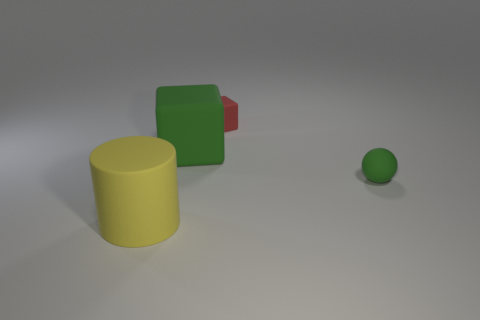Add 3 large yellow objects. How many objects exist? 7 Subtract all spheres. How many objects are left? 3 Subtract 0 red balls. How many objects are left? 4 Subtract all rubber objects. Subtract all big red rubber cubes. How many objects are left? 0 Add 4 tiny matte objects. How many tiny matte objects are left? 6 Add 3 large purple rubber objects. How many large purple rubber objects exist? 3 